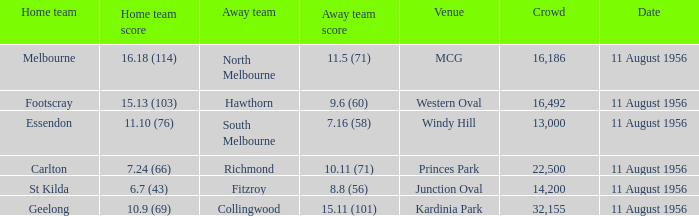Which home team possesses a score of 1 Melbourne. 